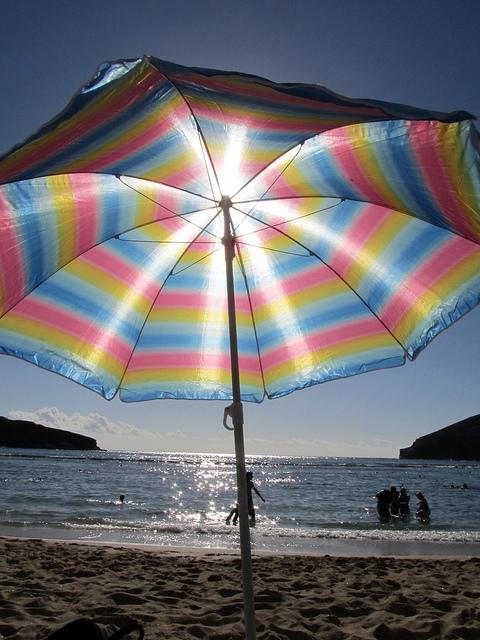What is the water like?
Keep it brief. Calm. What kind of scene is this?
Concise answer only. Beach. What color is the umbrella?
Answer briefly. Rainbow. How many umbrellas can you see in this photo?
Write a very short answer. 1. Are there people in the water?
Keep it brief. Yes. How many support wires can we count in the umbrella?
Write a very short answer. 8. 